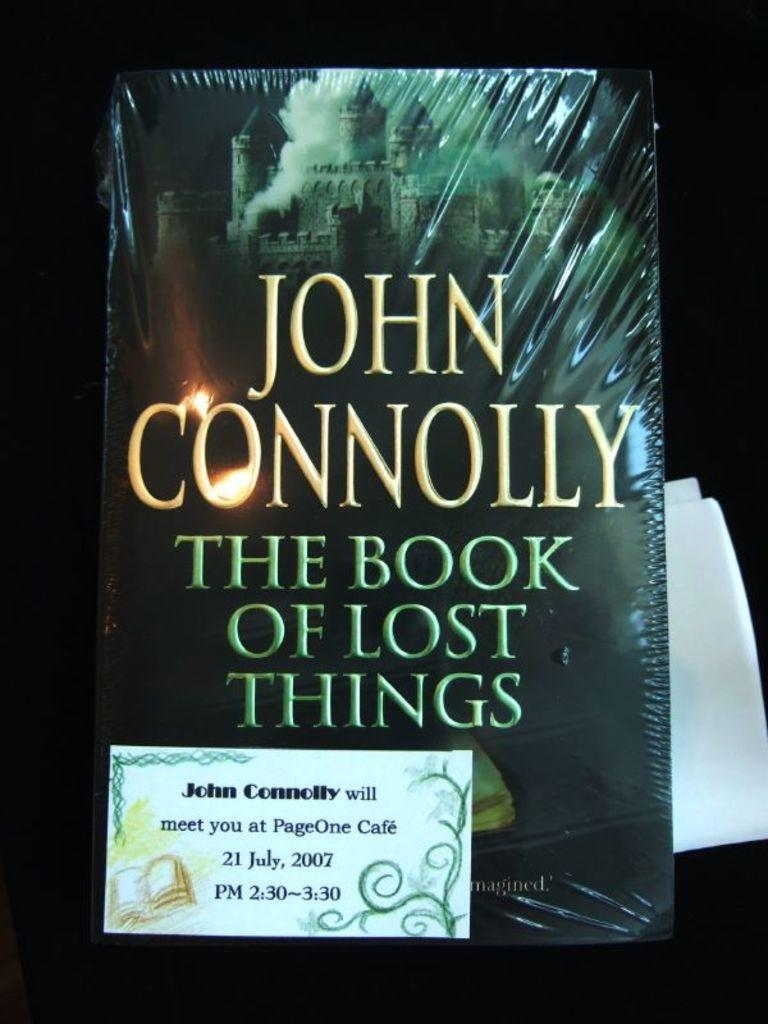<image>
Give a short and clear explanation of the subsequent image. A shrink wrapped book that is titled The Book Of Lost Things, by John Connolly. 